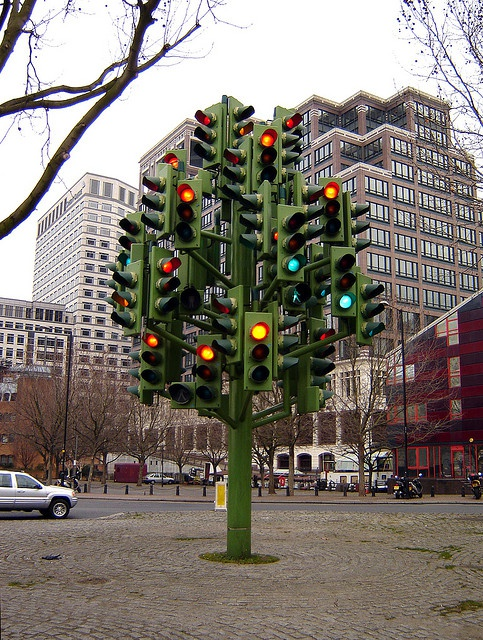Describe the objects in this image and their specific colors. I can see traffic light in white, black, darkgreen, and gray tones, truck in white, black, gray, and darkgray tones, traffic light in white, black, darkgreen, gray, and olive tones, traffic light in white, black, darkgreen, and green tones, and traffic light in white, black, darkgreen, and yellow tones in this image. 